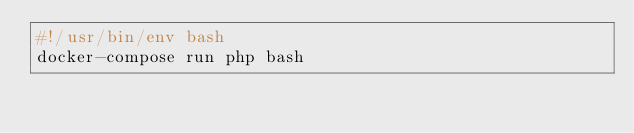Convert code to text. <code><loc_0><loc_0><loc_500><loc_500><_Bash_>#!/usr/bin/env bash
docker-compose run php bash</code> 